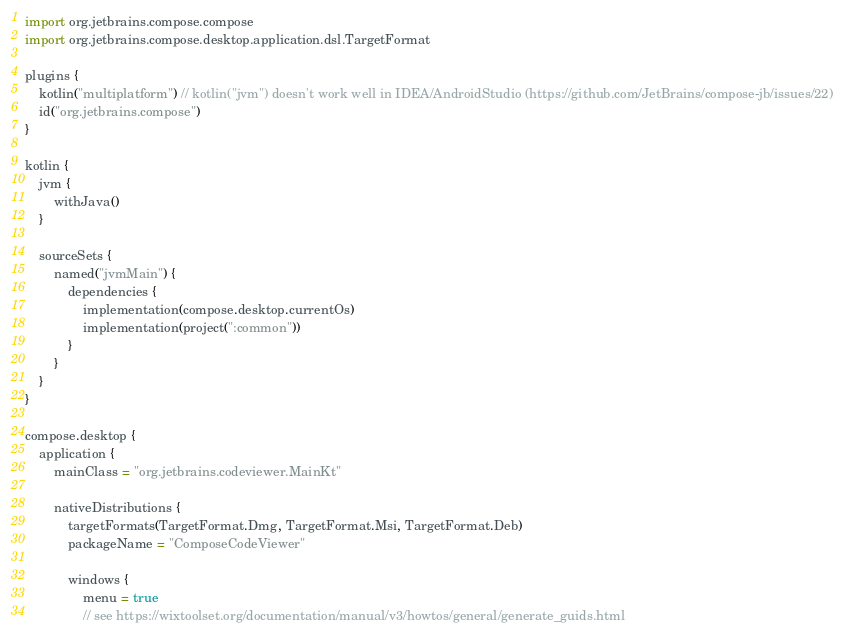<code> <loc_0><loc_0><loc_500><loc_500><_Kotlin_>import org.jetbrains.compose.compose
import org.jetbrains.compose.desktop.application.dsl.TargetFormat

plugins {
    kotlin("multiplatform") // kotlin("jvm") doesn't work well in IDEA/AndroidStudio (https://github.com/JetBrains/compose-jb/issues/22)
    id("org.jetbrains.compose")
}

kotlin {
    jvm {
        withJava()
    }

    sourceSets {
        named("jvmMain") {
            dependencies {
                implementation(compose.desktop.currentOs)
                implementation(project(":common"))
            }
        }
    }
}

compose.desktop {
    application {
        mainClass = "org.jetbrains.codeviewer.MainKt"

        nativeDistributions {
            targetFormats(TargetFormat.Dmg, TargetFormat.Msi, TargetFormat.Deb)
            packageName = "ComposeCodeViewer"

            windows {
                menu = true
                // see https://wixtoolset.org/documentation/manual/v3/howtos/general/generate_guids.html</code> 